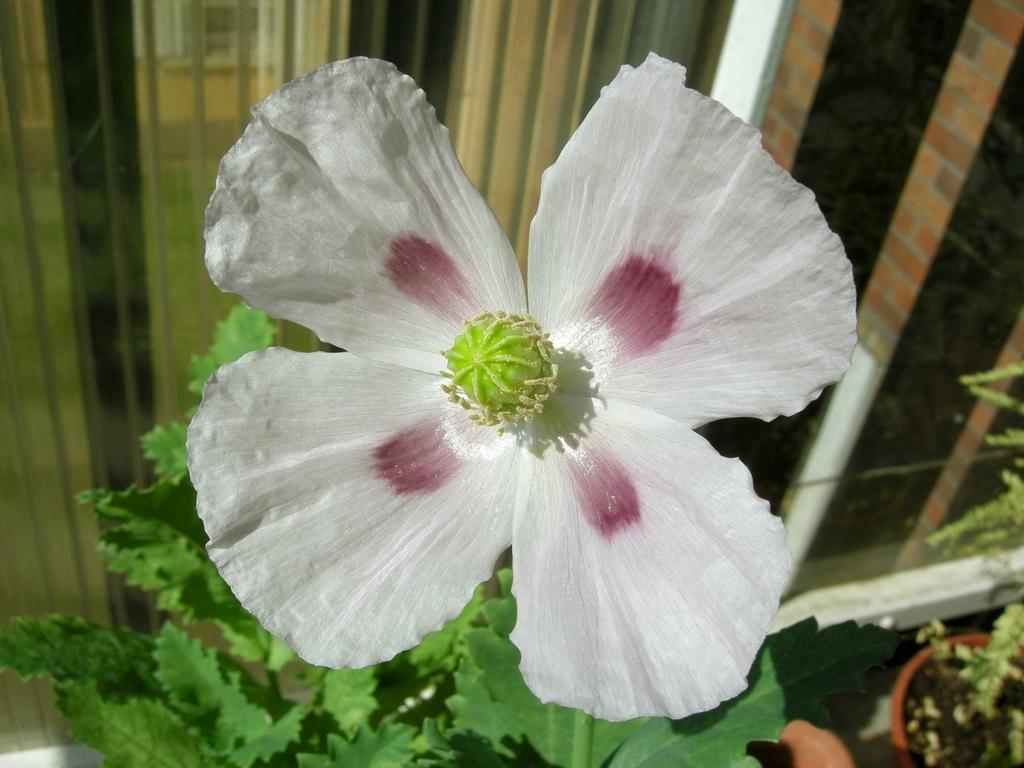What is the main subject in the center of the image? There is a flower in the center of the image. What other plant-related elements can be seen? There are plants in the image. What can be seen in the background of the image? There is a window and a wall in the background of the image. What is the cause of the rain seen in the image? There is no rain present in the image; it only features a flower, plants, a window, and a wall. 